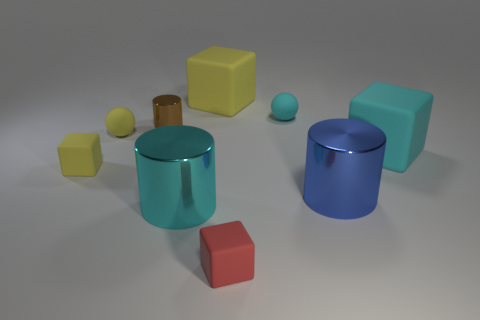There is a matte ball in front of the tiny brown cylinder; what number of large shiny objects are behind it?
Your response must be concise. 0. There is a block that is behind the small object that is to the right of the block in front of the large blue shiny cylinder; how big is it?
Your response must be concise. Large. What color is the object behind the small rubber ball that is right of the cyan cylinder?
Your answer should be compact. Yellow. How many other things are the same material as the big cyan cylinder?
Provide a succinct answer. 2. What is the material of the tiny block on the right side of the small cube that is behind the blue metal thing?
Offer a very short reply. Rubber. Are there any green things?
Your answer should be very brief. No. There is a matte cube that is left of the cyan thing that is to the left of the cyan rubber sphere; what size is it?
Make the answer very short. Small. Are there more brown shiny objects to the left of the brown metal thing than objects that are on the left side of the tiny cyan matte thing?
Offer a terse response. No. How many cylinders are either large blue things or large metal things?
Offer a very short reply. 2. Is there any other thing that is the same size as the cyan cube?
Make the answer very short. Yes. 